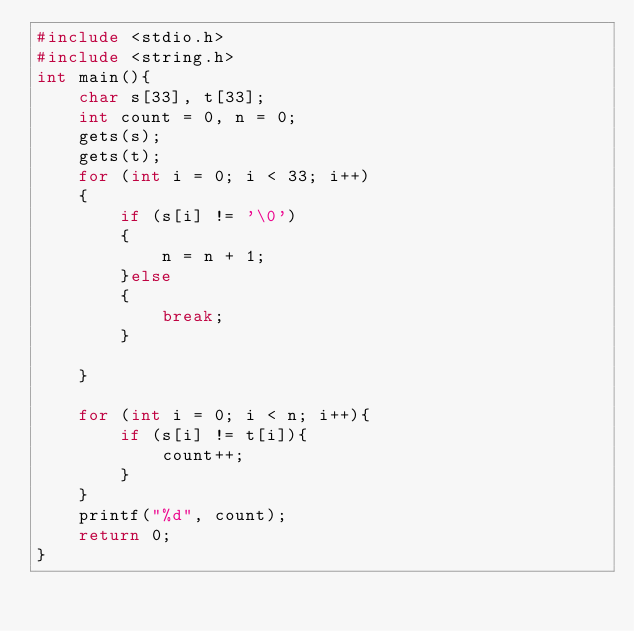<code> <loc_0><loc_0><loc_500><loc_500><_C_>#include <stdio.h>
#include <string.h>
int main(){
    char s[33], t[33];
    int count = 0, n = 0;
    gets(s);
    gets(t);
    for (int i = 0; i < 33; i++)
    {
        if (s[i] != '\0')
        {
            n = n + 1;
        }else
        {
            break;
        }
        
    }
    
    for (int i = 0; i < n; i++){
        if (s[i] != t[i]){
            count++;
        }
    }
    printf("%d", count);
    return 0;
}</code> 